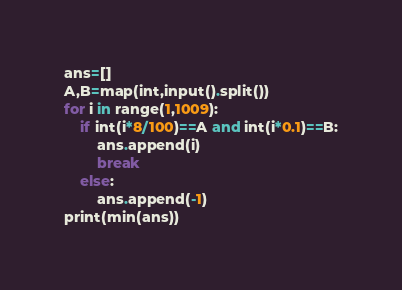Convert code to text. <code><loc_0><loc_0><loc_500><loc_500><_Python_>ans=[]
A,B=map(int,input().split())
for i in range(1,1009):
    if int(i*8/100)==A and int(i*0.1)==B:
        ans.append(i)
        break
    else:
        ans.append(-1)
print(min(ans))</code> 